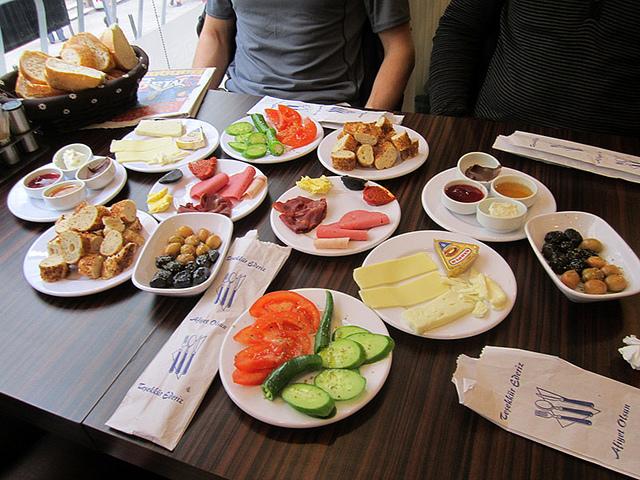Is this a healthy breakfast?
Short answer required. Yes. How many plates are on the table?
Give a very brief answer. 10. What nationality does this food represent?
Short answer required. Japanese. How many more serving plates are there compared to dinner plates?
Give a very brief answer. 2. 